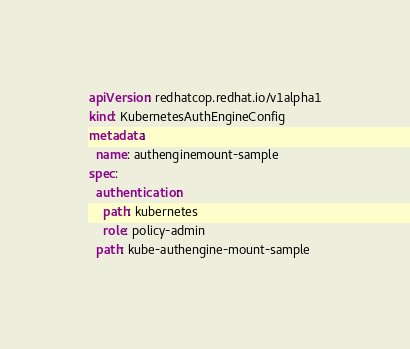<code> <loc_0><loc_0><loc_500><loc_500><_YAML_>apiVersion: redhatcop.redhat.io/v1alpha1
kind: KubernetesAuthEngineConfig
metadata:
  name: authenginemount-sample
spec:
  authentication: 
    path: kubernetes
    role: policy-admin
  path: kube-authengine-mount-sample</code> 